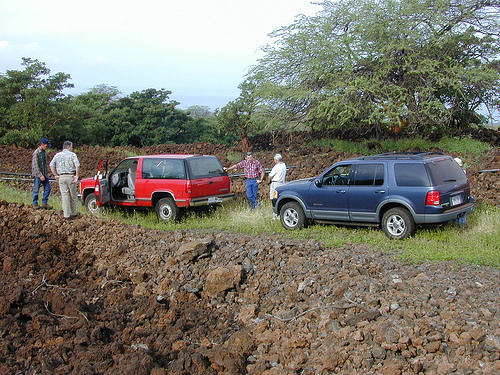<image>
Is the man to the right of the red car? Yes. From this viewpoint, the man is positioned to the right side relative to the red car. 